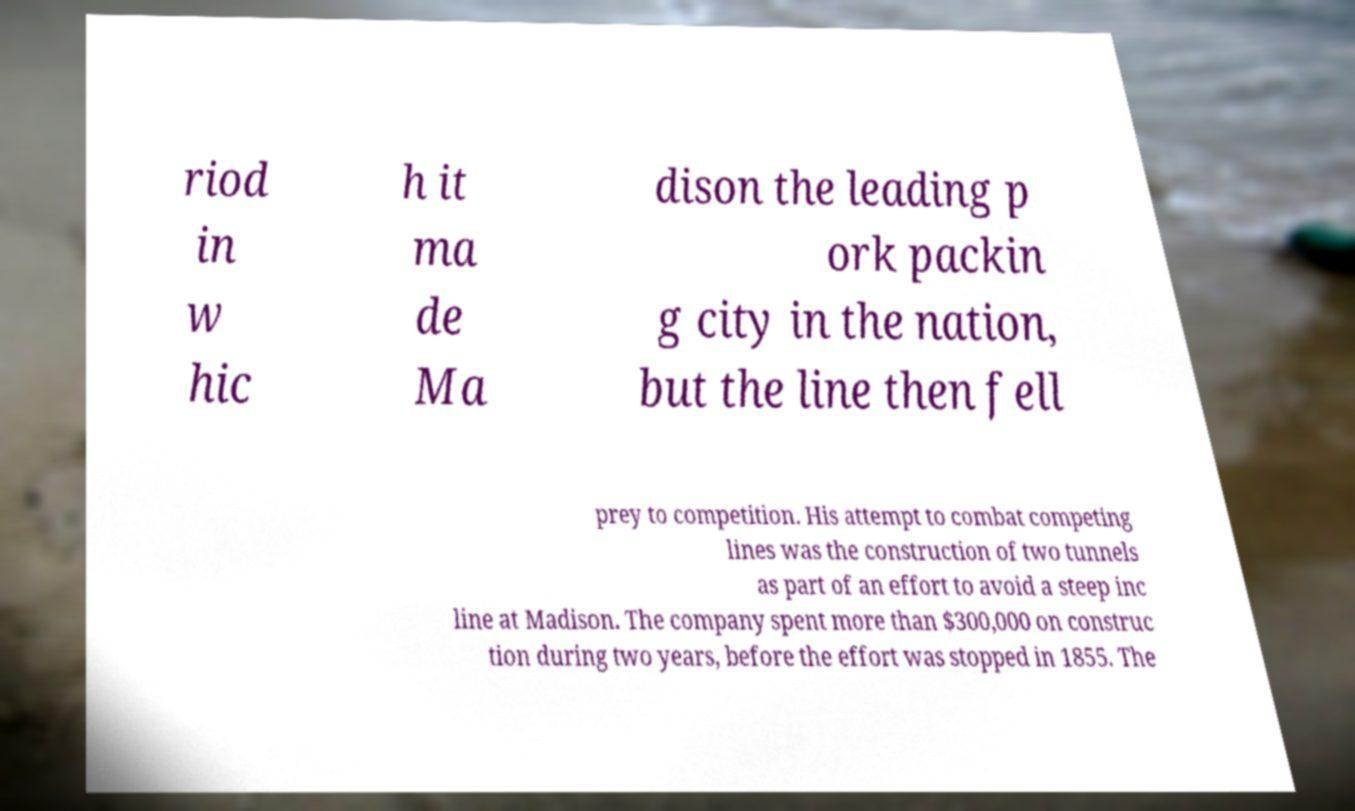Can you read and provide the text displayed in the image?This photo seems to have some interesting text. Can you extract and type it out for me? riod in w hic h it ma de Ma dison the leading p ork packin g city in the nation, but the line then fell prey to competition. His attempt to combat competing lines was the construction of two tunnels as part of an effort to avoid a steep inc line at Madison. The company spent more than $300,000 on construc tion during two years, before the effort was stopped in 1855. The 